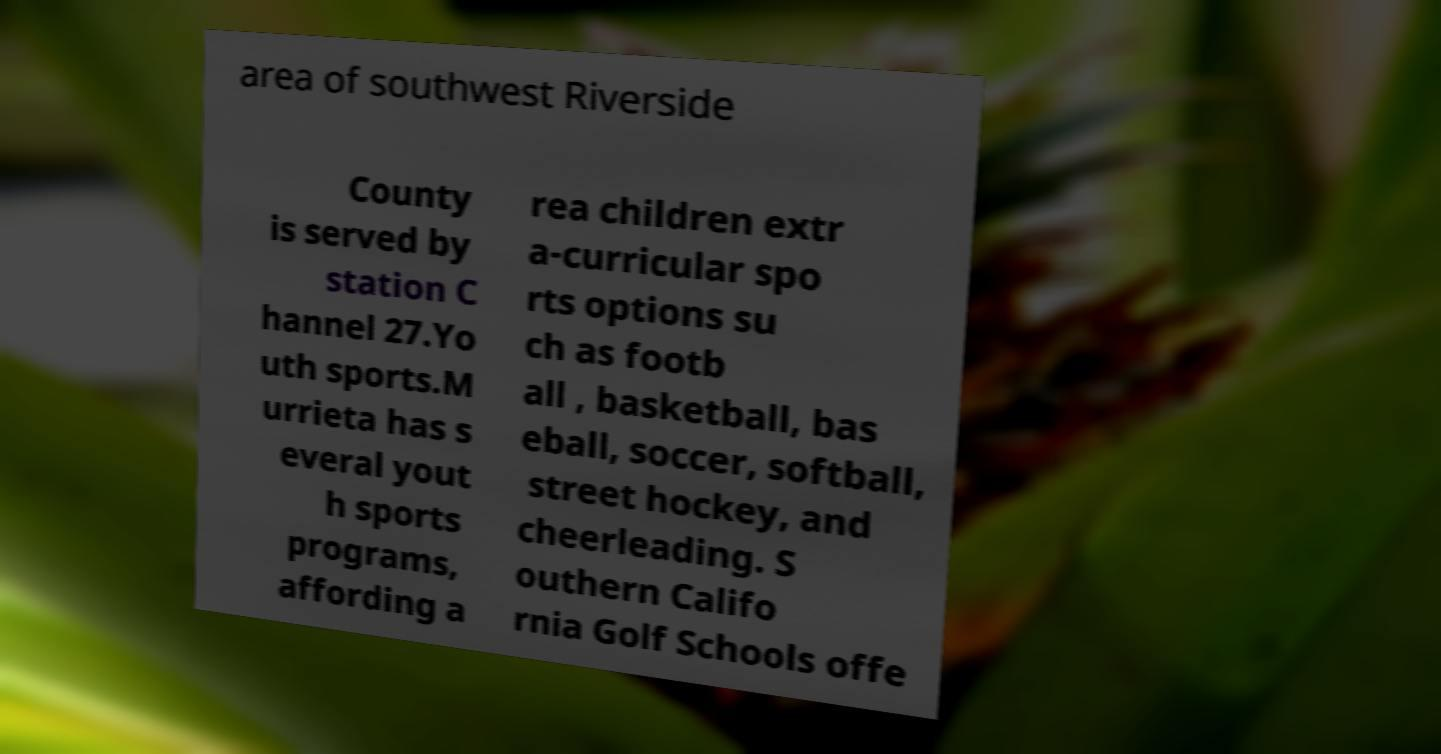Could you extract and type out the text from this image? area of southwest Riverside County is served by station C hannel 27.Yo uth sports.M urrieta has s everal yout h sports programs, affording a rea children extr a-curricular spo rts options su ch as footb all , basketball, bas eball, soccer, softball, street hockey, and cheerleading. S outhern Califo rnia Golf Schools offe 